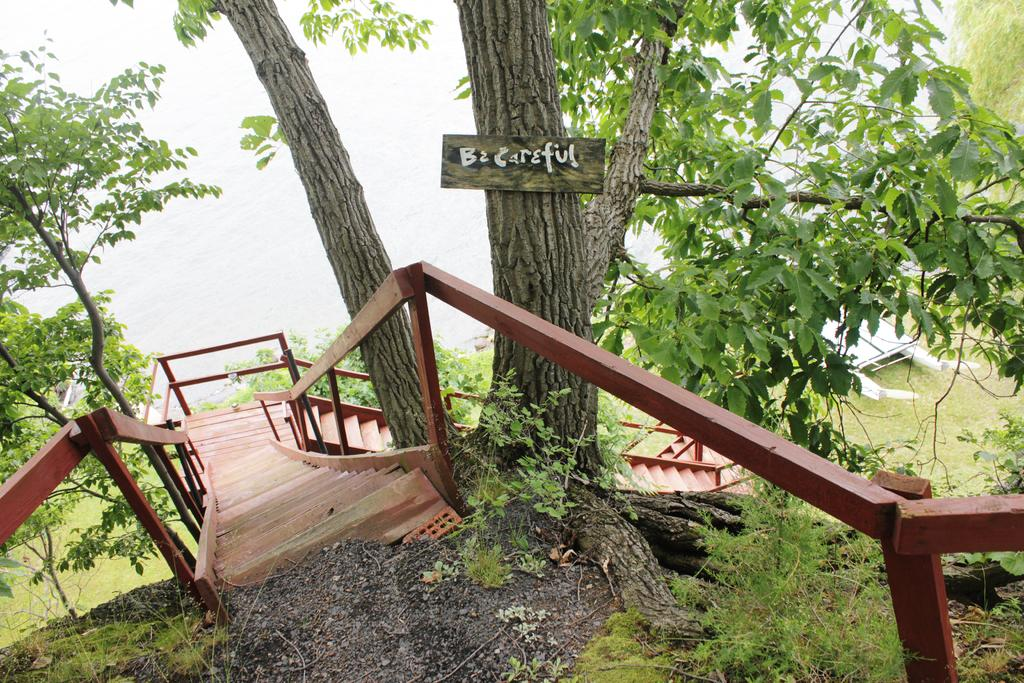What type of objects can be seen in the image? There are metal rods in the image. What natural elements are present in the image? There are trees and water visible in the image. What type of vehicle is in the image? There is a boat in the image. Can you see the development of a new city in the image? There is no indication of a new city or development in the image; it features metal rods, trees, water, and a boat. How many ducks are swimming in the water in the image? There are no ducks present in the image; it features trees, water, and a boat. 